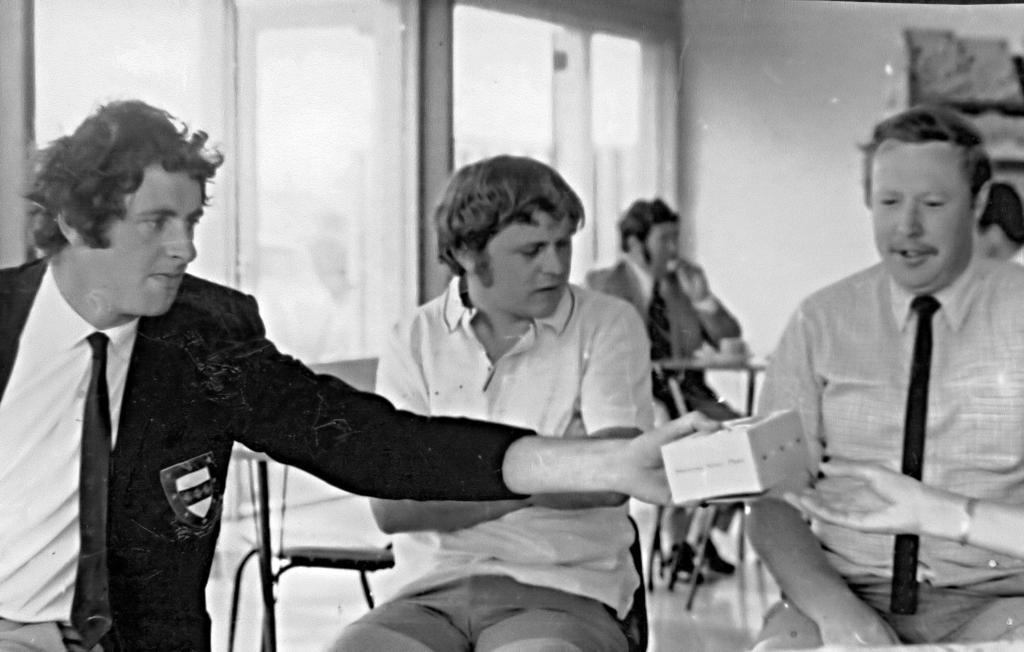Please provide a concise description of this image. In this image I see 4 men who are sitting on chairs and this man is holding a box in his hand and I see a person's hand over here. In the background I see the wall and I see the floor and I see that this is a black and white image. 